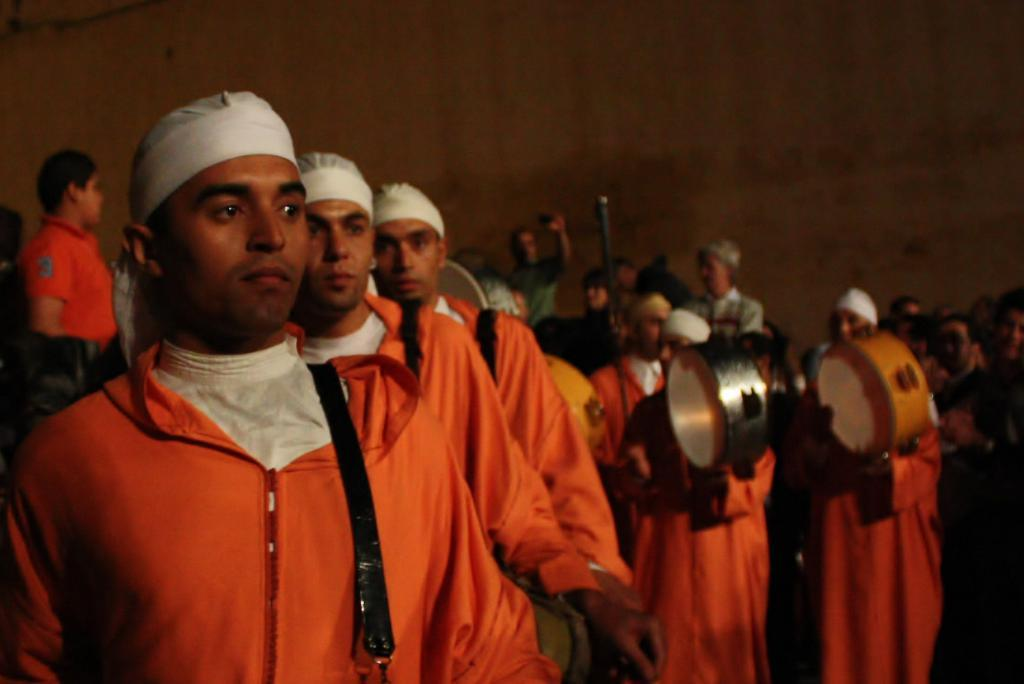What is the main subject of the image? The main subject of the image is a person standing in the center. What is the person holding in the image? The person is holding musical instruments. What can be seen in the background of the image? There is a wall in the background of the image. What country is the person from in the image? There is no information about the person's country of origin in the image. What reward does the person receive for playing the musical instruments in the image? There is no indication of a reward being given in the image. 